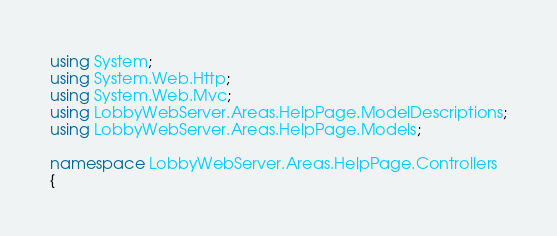<code> <loc_0><loc_0><loc_500><loc_500><_C#_>using System;
using System.Web.Http;
using System.Web.Mvc;
using LobbyWebServer.Areas.HelpPage.ModelDescriptions;
using LobbyWebServer.Areas.HelpPage.Models;

namespace LobbyWebServer.Areas.HelpPage.Controllers
{</code> 